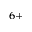<formula> <loc_0><loc_0><loc_500><loc_500>^ { 6 + }</formula> 